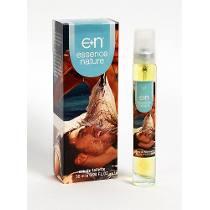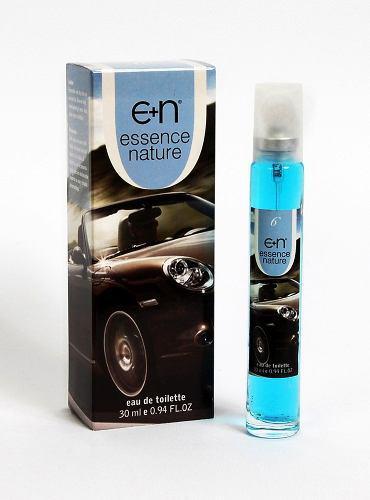The first image is the image on the left, the second image is the image on the right. Analyze the images presented: Is the assertion "Both images shows a perfume box with a human being on it." valid? Answer yes or no. No. The first image is the image on the left, the second image is the image on the right. Assess this claim about the two images: "A young woman is featured on the front of the bottle.". Correct or not? Answer yes or no. No. 